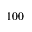<formula> <loc_0><loc_0><loc_500><loc_500>1 0 0</formula> 